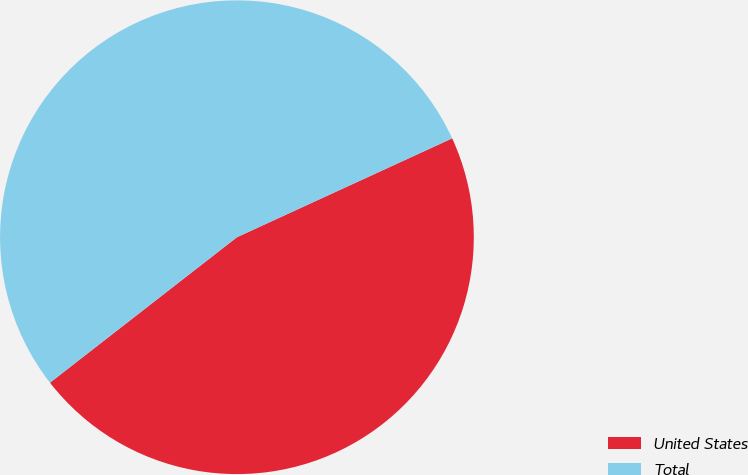Convert chart to OTSL. <chart><loc_0><loc_0><loc_500><loc_500><pie_chart><fcel>United States<fcel>Total<nl><fcel>46.33%<fcel>53.67%<nl></chart> 